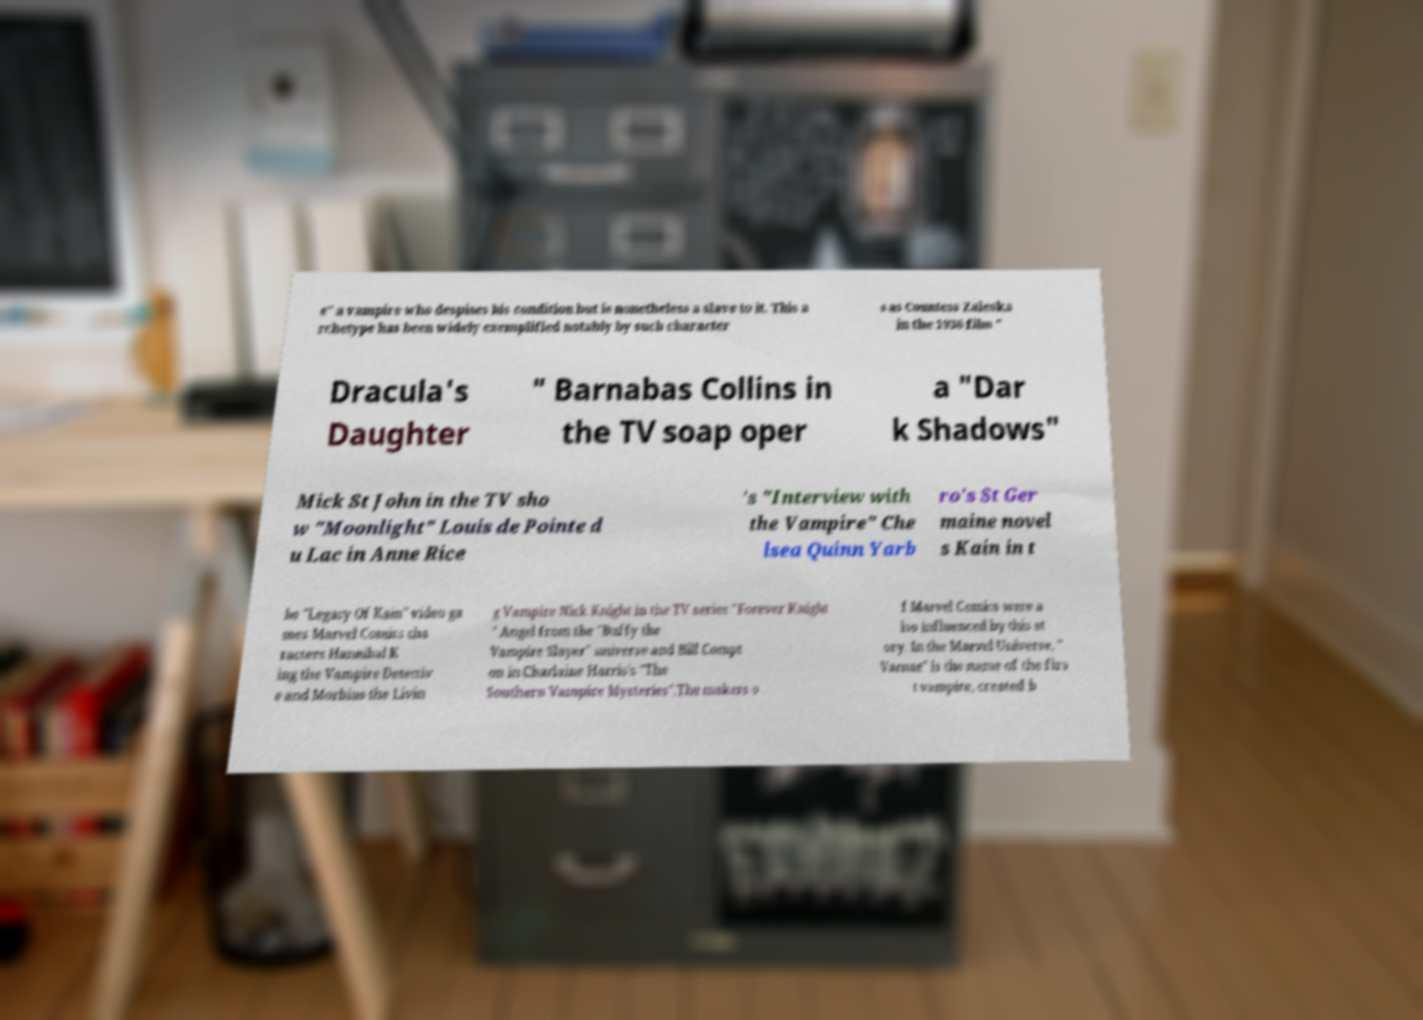Can you read and provide the text displayed in the image?This photo seems to have some interesting text. Can you extract and type it out for me? e" a vampire who despises his condition but is nonetheless a slave to it. This a rchetype has been widely exemplified notably by such character s as Countess Zaleska in the 1936 film " Dracula's Daughter " Barnabas Collins in the TV soap oper a "Dar k Shadows" Mick St John in the TV sho w "Moonlight" Louis de Pointe d u Lac in Anne Rice 's "Interview with the Vampire" Che lsea Quinn Yarb ro's St Ger maine novel s Kain in t he "Legacy Of Kain" video ga mes Marvel Comics cha racters Hannibal K ing the Vampire Detectiv e and Morbius the Livin g Vampire Nick Knight in the TV series "Forever Knight " Angel from the "Buffy the Vampire Slayer" universe and Bill Compt on in Charlaine Harris's "The Southern Vampire Mysteries".The makers o f Marvel Comics were a lso influenced by this st ory. In the Marvel Universe, " Varnae" is the name of the firs t vampire, created b 